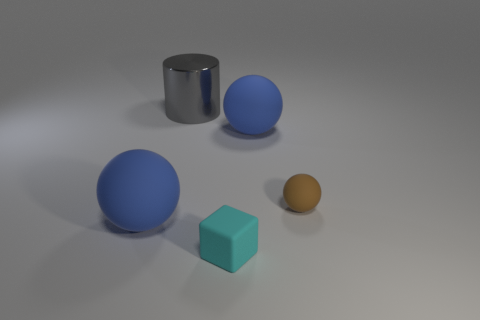Can you describe the lighting and shadows in the scene? The lighting in the scene is soft and diffused, suggesting an evenly lit environment, likely from above given the direction of the shadows. Each object casts a gentle shadow directly opposite the light source, which helps to enhance the three-dimensionality of the shapes and adds a sense of realism to the composition. 